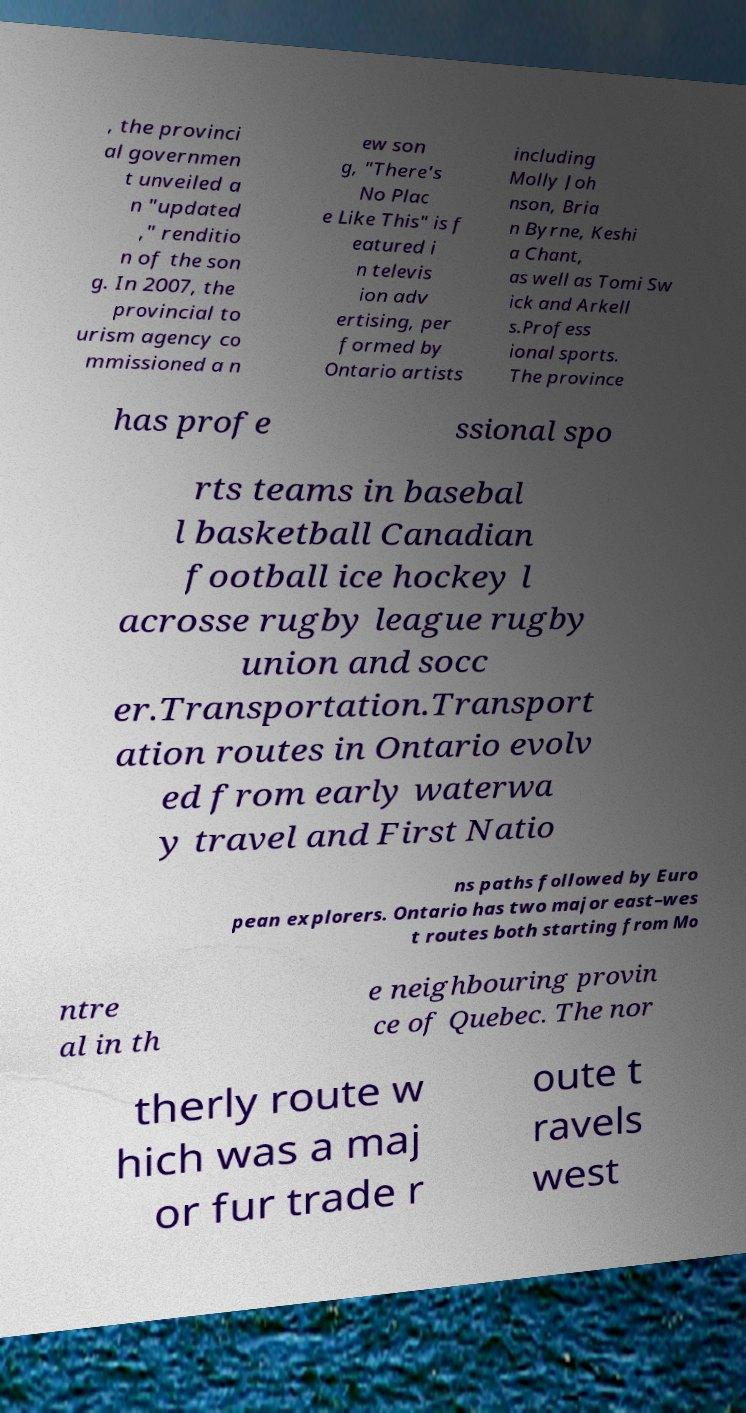There's text embedded in this image that I need extracted. Can you transcribe it verbatim? , the provinci al governmen t unveiled a n "updated ," renditio n of the son g. In 2007, the provincial to urism agency co mmissioned a n ew son g, "There's No Plac e Like This" is f eatured i n televis ion adv ertising, per formed by Ontario artists including Molly Joh nson, Bria n Byrne, Keshi a Chant, as well as Tomi Sw ick and Arkell s.Profess ional sports. The province has profe ssional spo rts teams in basebal l basketball Canadian football ice hockey l acrosse rugby league rugby union and socc er.Transportation.Transport ation routes in Ontario evolv ed from early waterwa y travel and First Natio ns paths followed by Euro pean explorers. Ontario has two major east–wes t routes both starting from Mo ntre al in th e neighbouring provin ce of Quebec. The nor therly route w hich was a maj or fur trade r oute t ravels west 